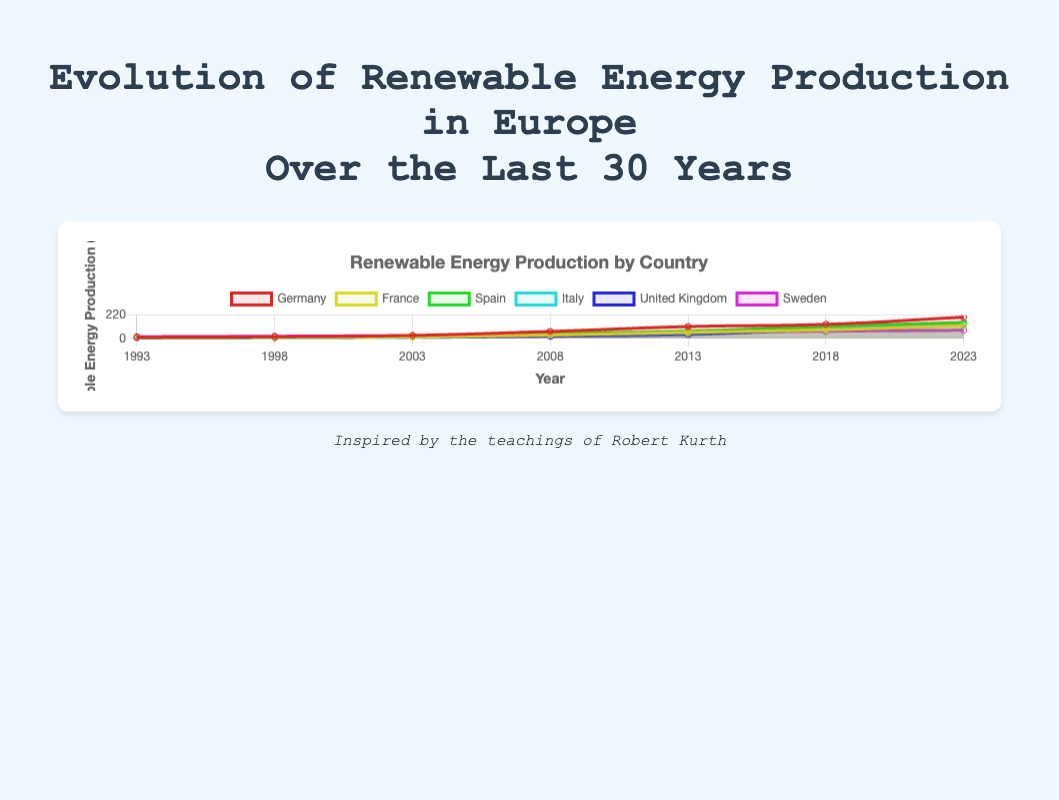Which country had the highest renewable energy production in 2023? In the line plot, we observe the value at the year 2023 for each country. Germany shows the highest value, reaching approximately 200.7 TWh in 2023.
Answer: Germany What is the total renewable energy production of all six countries in 2018? To find the total renewable energy production in 2018, we add the values for all six countries: Germany (132.5) + France (80.3) + Spain (112.6) + Italy (89.4) + United Kingdom (85.0) + Sweden (67.3) = 567.1 TWh.
Answer: 567.1 TWh Which country had the lowest renewable energy production in 1993, and what was the value? We examine the values at 1993 for each country. The United Kingdom had the lowest value, which was 2.8 TWh.
Answer: United Kingdom, 2.8 TWh Between 2008 and 2013, which country had the highest increase in renewable energy production? To determine this, we calculate the difference in renewable energy production between 2008 and 2013 for each country: Germany (111.3 - 65.0 = 46.3), France (56.8 - 31.2 = 25.6), Spain (68.0 - 45.9 = 22.1), Italy (54.2 - 33.5 = 20.7), United Kingdom (35.6 - 19.2 = 16.4), Sweden (52.6 - 40.5 = 12.1). Germany had the highest increase.
Answer: Germany What is the average renewable energy production in 2023 across all countries? To find the average renewable energy production in 2023, we sum the values and then divide by the number of countries: (200.7 + 120.1 + 150.4 + 130.8 + 134.7 + 75.9) / 6 = 812.6 / 6 ≈ 135.4 TWh.
Answer: 135.4 TWh Which country shows the steadier growth in renewable energy production based on the consistent increase in the line over the years? By observing the trend lines in the plot, Sweden shows a steadier and more consistent growth without large fluctuations or rapid increases compared to other countries.
Answer: Sweden In which year did Germany surpass 50 TWh in renewable energy production? By examining Germany's renewable energy production over the years, we observe that it surpassed 50 TWh in the year 2008 (65.0 TWh).
Answer: 2008 